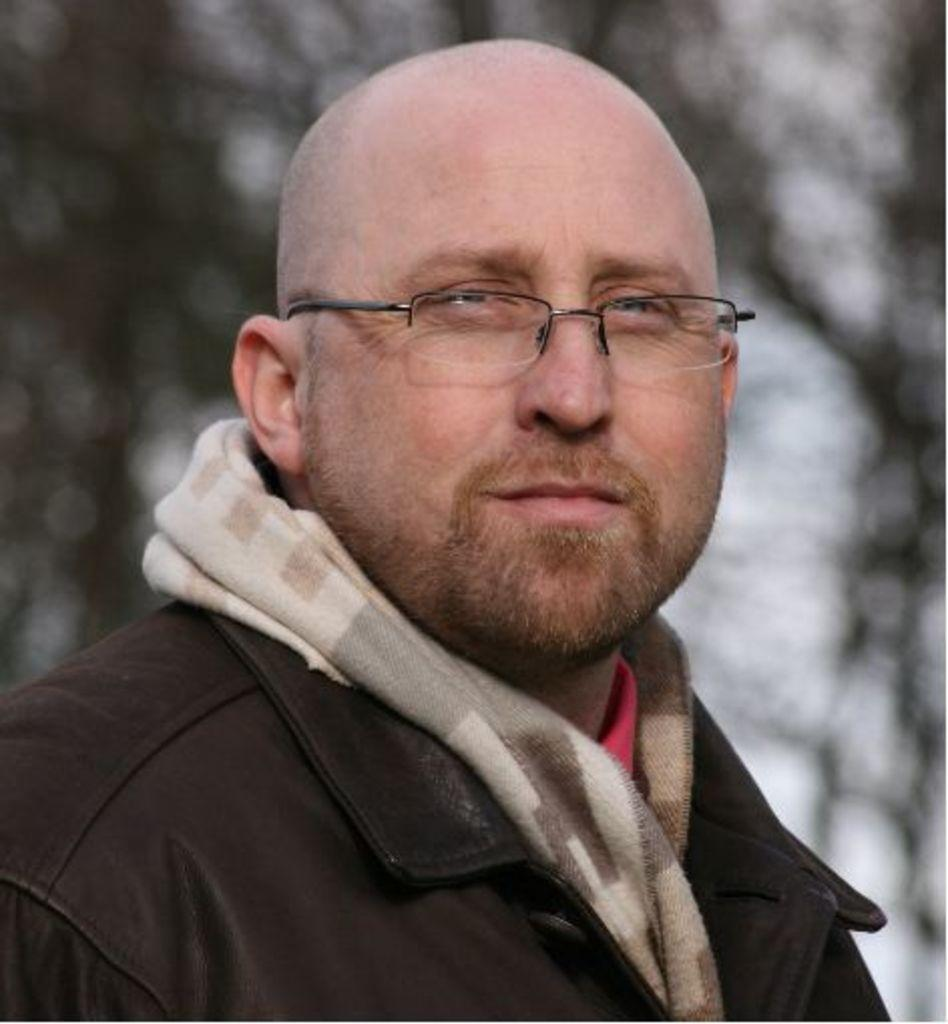Who is the main subject in the image? There is a man in the center of the image. What type of hydrant can be seen sticking out of the man's tongue in the image? There is no hydrant or any object sticking out of the man's tongue in the image. 